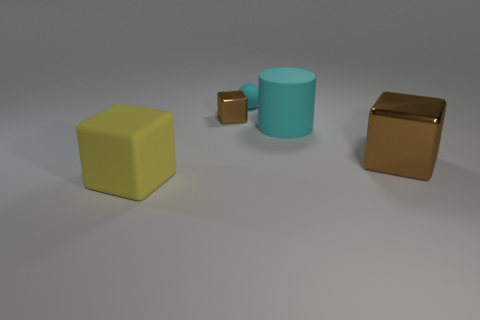What is the shape of the big matte thing that is the same color as the tiny ball?
Make the answer very short. Cylinder. There is a cube that is both on the left side of the big brown shiny cube and in front of the big rubber cylinder; what is its material?
Your answer should be very brief. Rubber. Is the number of brown metal objects less than the number of big yellow rubber objects?
Your response must be concise. No. There is a small metallic thing; does it have the same shape as the big matte thing right of the large yellow matte cube?
Your answer should be compact. No. Does the shiny block that is to the right of the cyan cylinder have the same size as the tiny rubber object?
Your response must be concise. No. What is the shape of the object that is the same size as the cyan rubber sphere?
Ensure brevity in your answer.  Cube. Is the shape of the tiny cyan thing the same as the big cyan thing?
Offer a very short reply. No. How many yellow objects are the same shape as the tiny cyan object?
Provide a succinct answer. 0. How many large brown objects are behind the big cyan matte cylinder?
Provide a succinct answer. 0. There is a matte ball that is behind the tiny brown cube; is it the same color as the small cube?
Your response must be concise. No. 